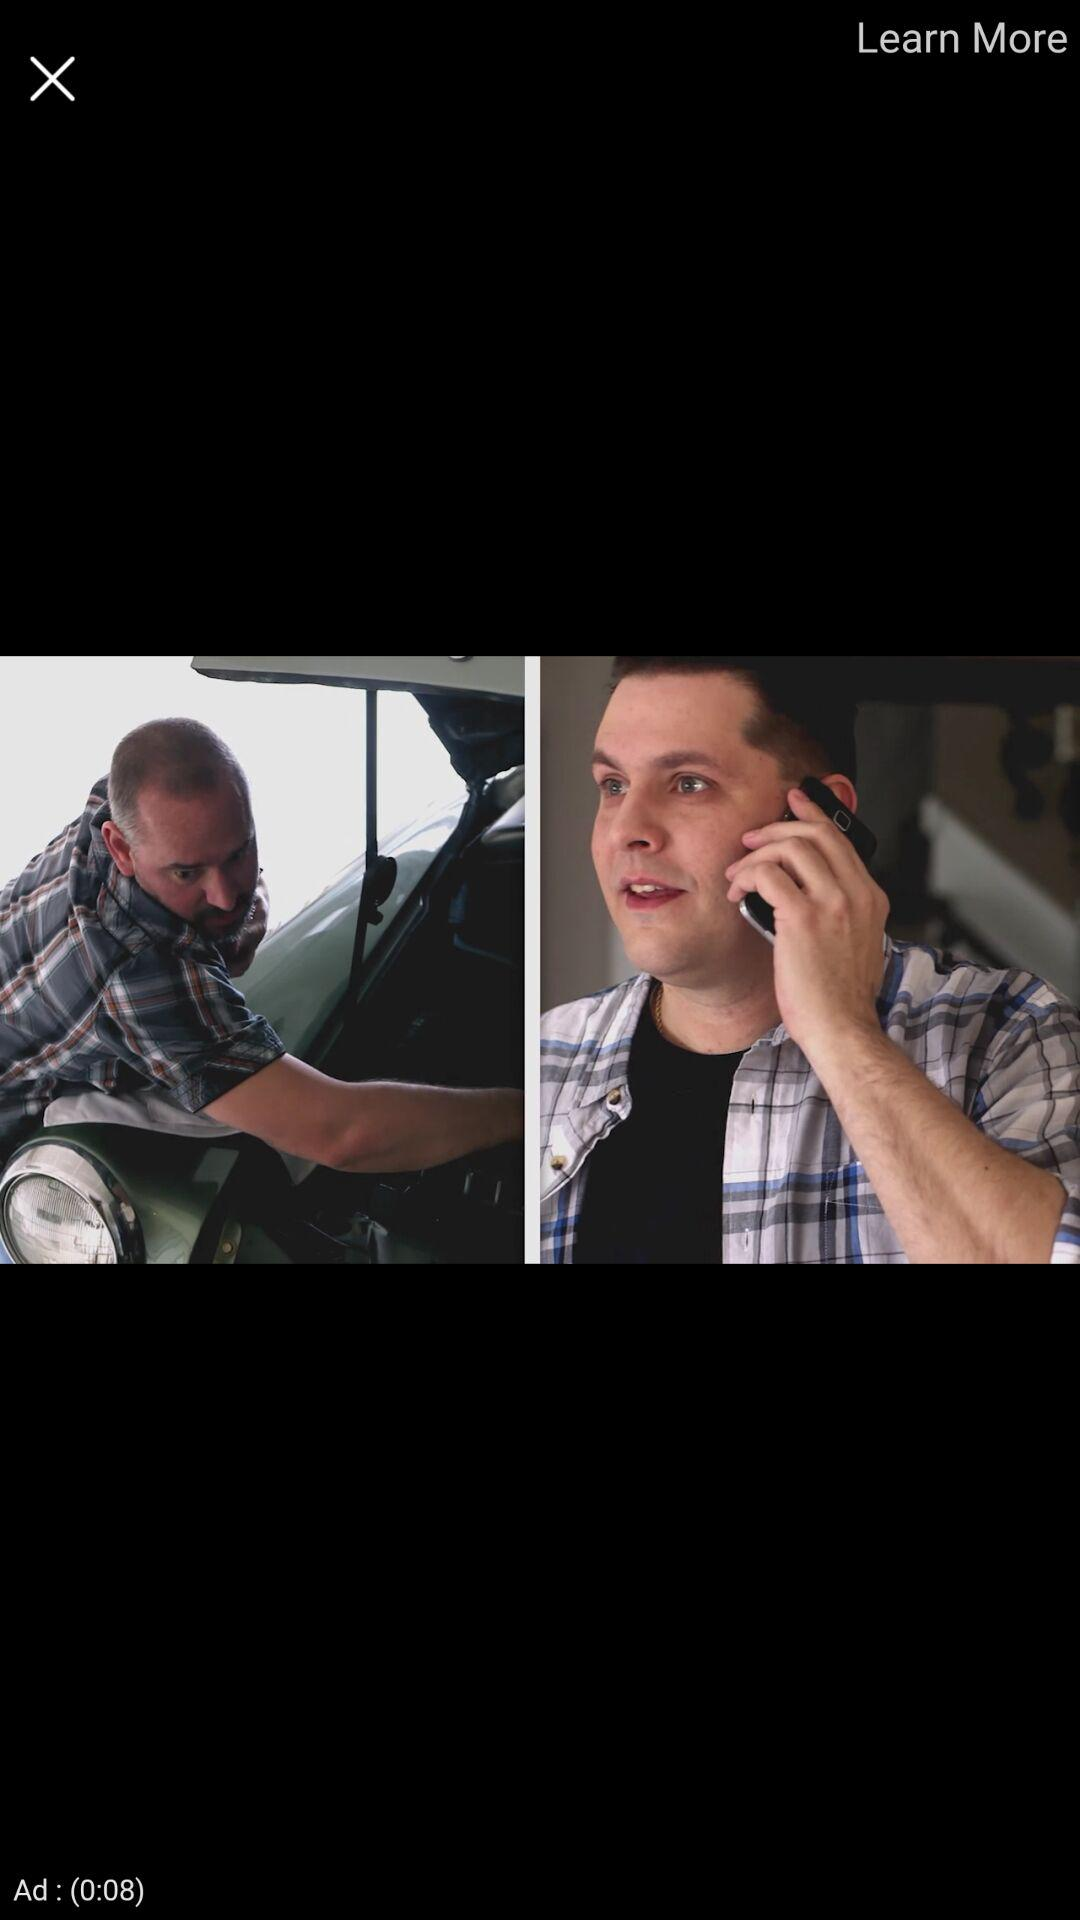How many more seconds than minutes is the ad?
Answer the question using a single word or phrase. 8 